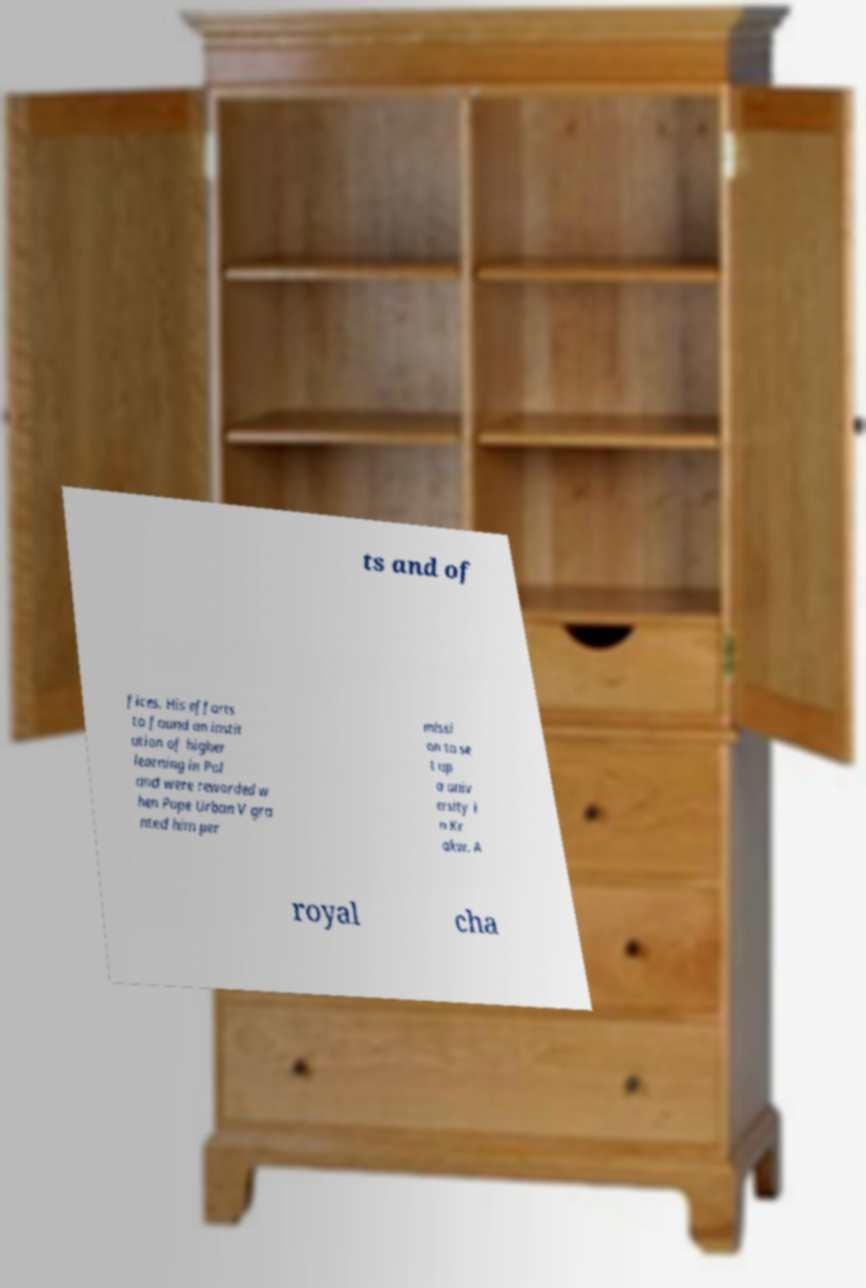Please identify and transcribe the text found in this image. ts and of fices. His efforts to found an instit ution of higher learning in Pol and were rewarded w hen Pope Urban V gra nted him per missi on to se t up a univ ersity i n Kr akw. A royal cha 